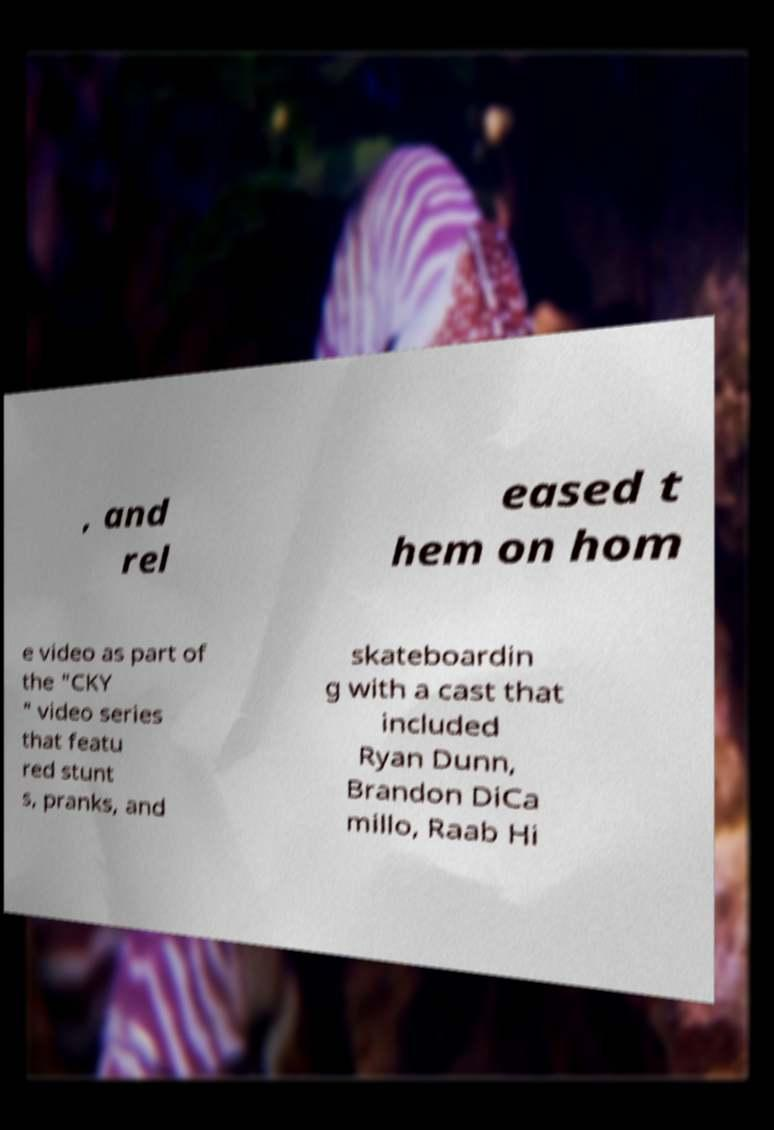Can you accurately transcribe the text from the provided image for me? , and rel eased t hem on hom e video as part of the "CKY " video series that featu red stunt s, pranks, and skateboardin g with a cast that included Ryan Dunn, Brandon DiCa millo, Raab Hi 